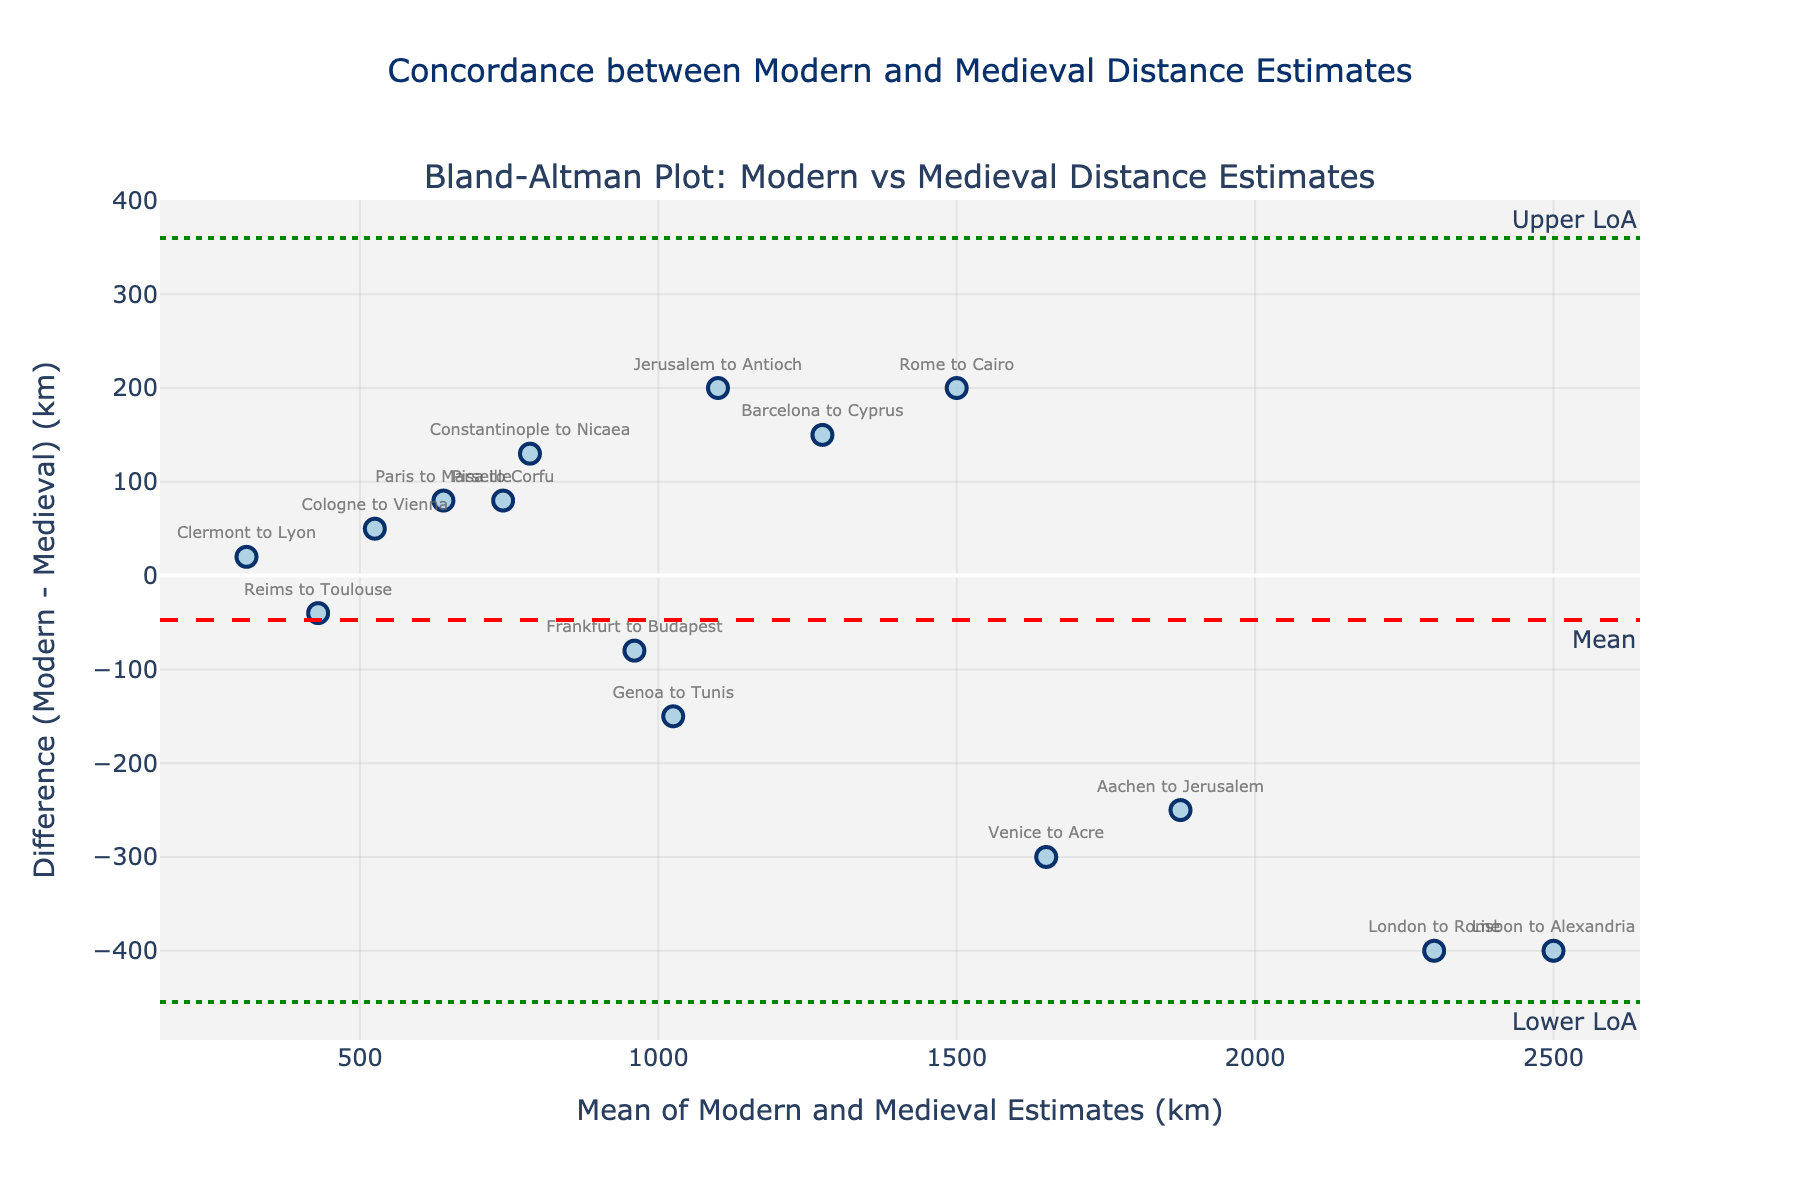What is the title of the figure? The title is usually positioned at the top center of the plot. Here, the title states "Concordance between Modern and Medieval Distance Estimates."
Answer: Concordance between Modern and Medieval Distance Estimates What are the units used for the mean and difference in the plot? The x-axis title mentions "Mean of Modern and Medieval Estimates (km)" and the y-axis title mentions "Difference (Modern - Medieval) (km)," indicating that the units are kilometers (km).
Answer: Kilometers (km) How many location estimates are shown in the plot? Each data point represents one location estimate. By counting the markers or checking the labels, you can determine there are 15 different location estimates.
Answer: 15 What is the mean difference between modern and medieval estimates marked by? The mean difference line is marked with a red dashed line annotated as "Mean."
Answer: Red dashed line Which location has the largest positive difference between modern and medieval estimates? By observing the y-values of the points, the largest positive value appears at "Lisbon to Alexandria," which has the highest positive difference.
Answer: Lisbon to Alexandria What are the upper and lower limits of agreement? The plot includes dotted green lines annotated as "Upper LoA" and "Lower LoA." By reading the values from these annotations, we can determine the upper and lower limits.
Answer: Upper LoA is approximately 781.2 km, Lower LoA is approximately -748.7 km Which locations have their mean estimates closest to 1500 km? By examining the x-values of data points, we can find points close to 1500 km. "Barcelona to Cyprus" and "Venice to Acre" seem closest to this mean value.
Answer: Barcelona to Cyprus, Venice to Acre Which location has the smallest mean estimate? The smallest x-value represents the smallest mean estimate. This appears to be "Reims to Toulouse."
Answer: Reims to Toulouse How many points fall outside the limits of agreement? By checking which points are beyond the dotted green lines, it appears that there are two points outside these limits: "Lisbon to Alexandria" and "London to Rome."
Answer: 2 Approximately, what is the average mean of the estimates? The names of the places and distances aren't needed to calculate the average; we need to average the mean values on the x-axis.
Answer: Approximately 1200 km 